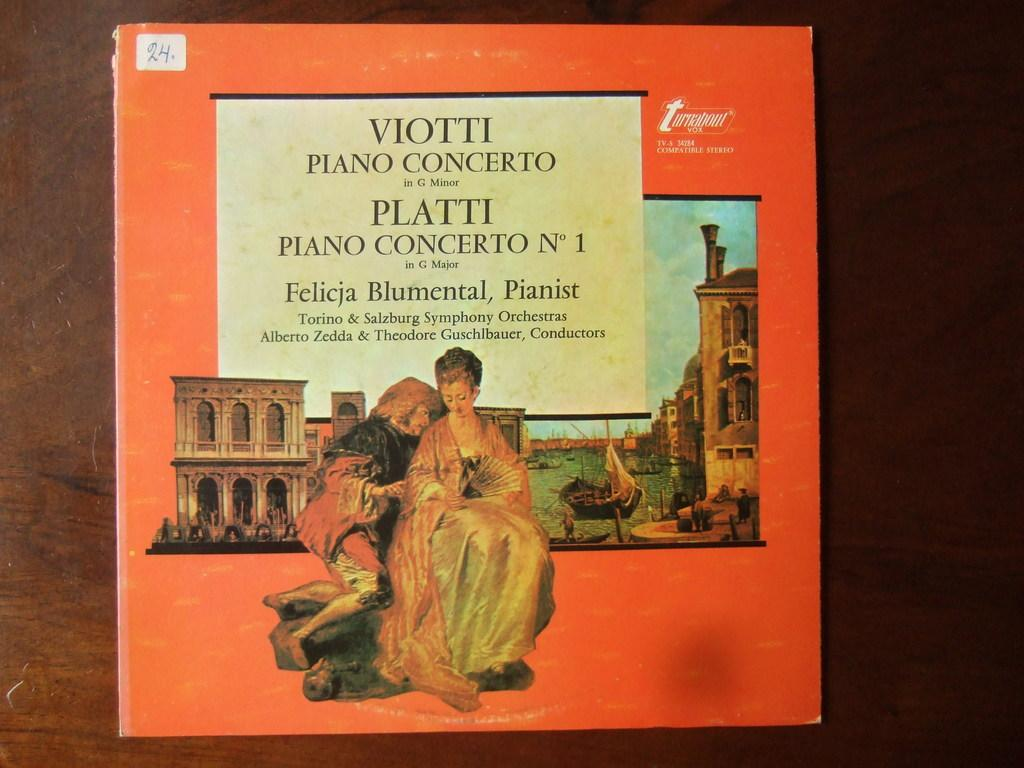<image>
Share a concise interpretation of the image provided. Cover of an album with the word VIOTTI near the top. 